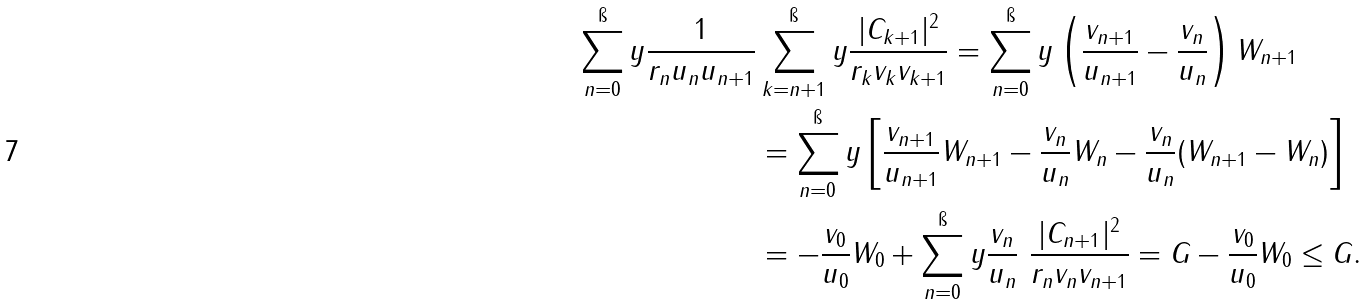<formula> <loc_0><loc_0><loc_500><loc_500>\sum _ { n = 0 } ^ { \i } y \frac { 1 } { r _ { n } u _ { n } u _ { n + 1 } } & \sum _ { k = n + 1 } ^ { \i } y \frac { | C _ { k + 1 } | ^ { 2 } } { r _ { k } v _ { k } v _ { k + 1 } } = \sum _ { n = 0 } ^ { \i } y \left ( \frac { v _ { n + 1 } } { u _ { n + 1 } } - \frac { v _ { n } } { u _ { n } } \right ) W _ { n + 1 } \\ & = \sum _ { n = 0 } ^ { \i } y \left [ \frac { v _ { n + 1 } } { u _ { n + 1 } } W _ { n + 1 } - \frac { v _ { n } } { u _ { n } } W _ { n } - \frac { v _ { n } } { u _ { n } } ( W _ { n + 1 } - W _ { n } ) \right ] \\ & = - \frac { v _ { 0 } } { u _ { 0 } } W _ { 0 } + \sum _ { n = 0 } ^ { \i } y \frac { v _ { n } } { u _ { n } } \ \frac { | C _ { n + 1 } | ^ { 2 } } { r _ { n } v _ { n } v _ { n + 1 } } = G - \frac { v _ { 0 } } { u _ { 0 } } W _ { 0 } \leq G .</formula> 